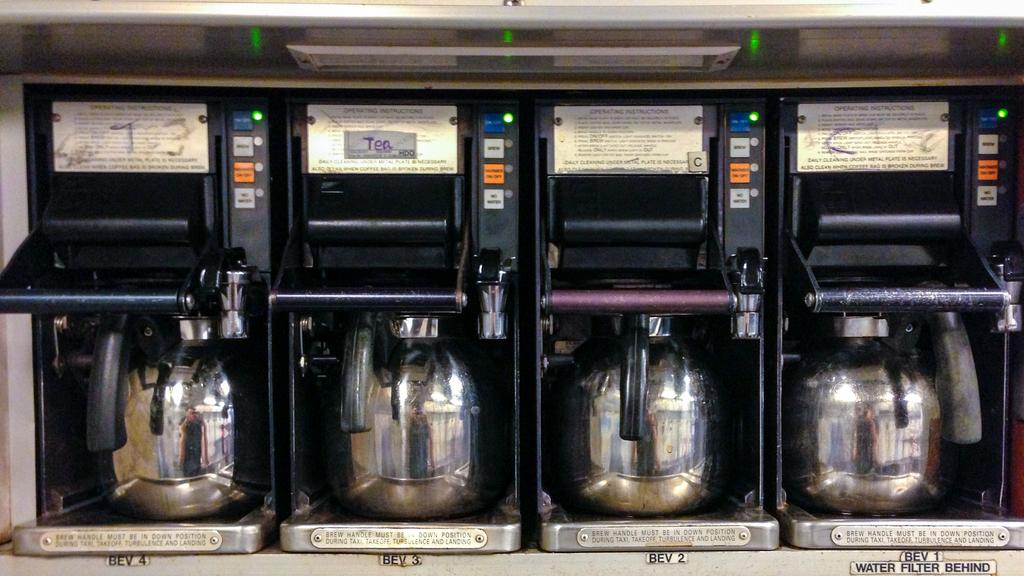What does it say under the very first coffee pot?
Give a very brief answer. Bev 4. 